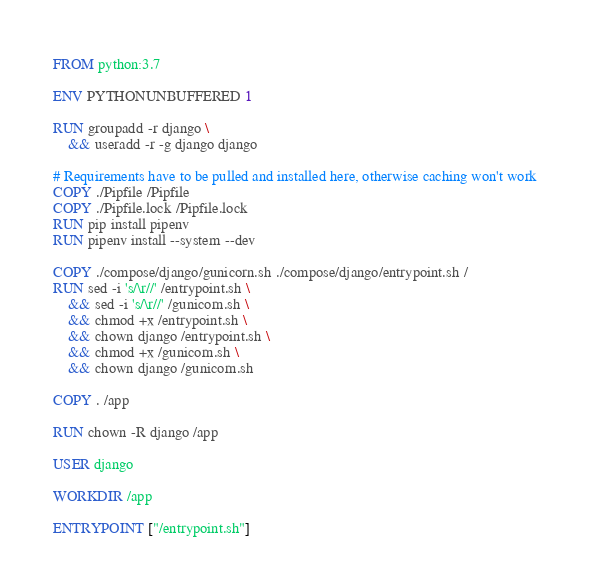<code> <loc_0><loc_0><loc_500><loc_500><_Dockerfile_>FROM python:3.7

ENV PYTHONUNBUFFERED 1

RUN groupadd -r django \
    && useradd -r -g django django

# Requirements have to be pulled and installed here, otherwise caching won't work
COPY ./Pipfile /Pipfile
COPY ./Pipfile.lock /Pipfile.lock
RUN pip install pipenv
RUN pipenv install --system --dev

COPY ./compose/django/gunicorn.sh ./compose/django/entrypoint.sh /
RUN sed -i 's/\r//' /entrypoint.sh \
    && sed -i 's/\r//' /gunicorn.sh \
    && chmod +x /entrypoint.sh \
    && chown django /entrypoint.sh \
    && chmod +x /gunicorn.sh \
    && chown django /gunicorn.sh

COPY . /app

RUN chown -R django /app

USER django

WORKDIR /app

ENTRYPOINT ["/entrypoint.sh"]
</code> 